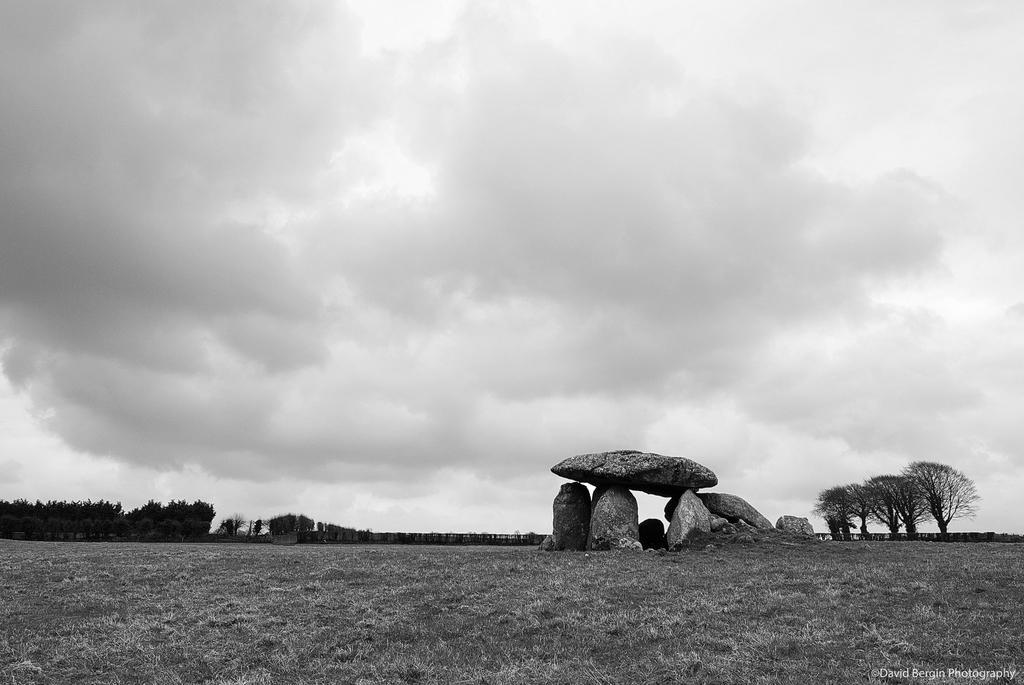Please provide a concise description of this image. In this picture we can see the grass, rocks, trees and some objects and in the background we can see the sky with clouds. 